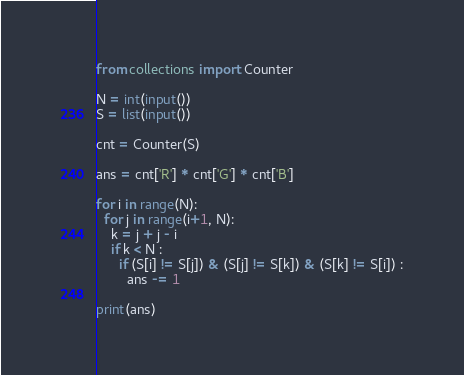<code> <loc_0><loc_0><loc_500><loc_500><_Python_>from collections import Counter

N = int(input())
S = list(input())

cnt = Counter(S)

ans = cnt['R'] * cnt['G'] * cnt['B']

for i in range(N):
  for j in range(i+1, N):
    k = j + j - i
    if k < N :
      if (S[i] != S[j]) & (S[j] != S[k]) & (S[k] != S[i]) :
        ans -= 1

print(ans)</code> 